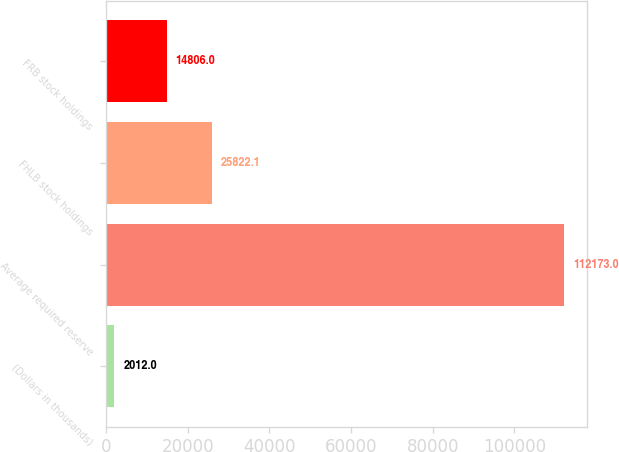Convert chart. <chart><loc_0><loc_0><loc_500><loc_500><bar_chart><fcel>(Dollars in thousands)<fcel>Average required reserve<fcel>FHLB stock holdings<fcel>FRB stock holdings<nl><fcel>2012<fcel>112173<fcel>25822.1<fcel>14806<nl></chart> 